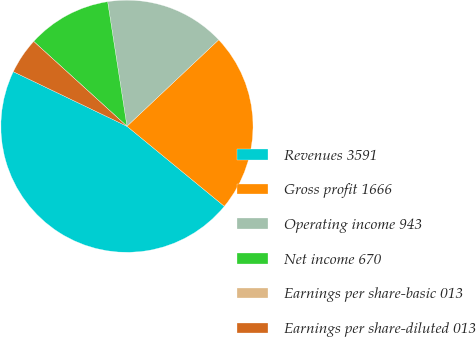Convert chart to OTSL. <chart><loc_0><loc_0><loc_500><loc_500><pie_chart><fcel>Revenues 3591<fcel>Gross profit 1666<fcel>Operating income 943<fcel>Net income 670<fcel>Earnings per share-basic 013<fcel>Earnings per share-diluted 013<nl><fcel>46.17%<fcel>22.98%<fcel>15.42%<fcel>10.81%<fcel>0.0%<fcel>4.62%<nl></chart> 